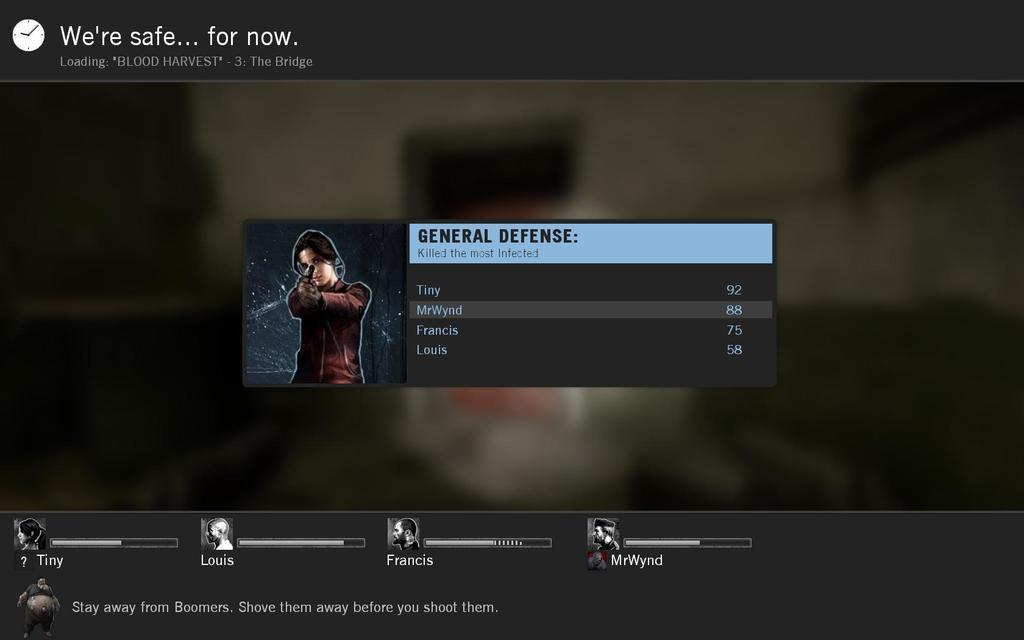What type of image is shown in the screenshot? The image appears to be a screenshot of a game. What else can be seen in the image besides the game? There is text visible in the image. Can you describe the animation in the image? There is an animation picture of a woman in the image. How many sheep are present in the image? There are no sheep visible in the image. What type of toothpaste is being used by the woman in the image? There is no toothpaste or woman present in the image; it is a screenshot of a game with an animation of a woman. 